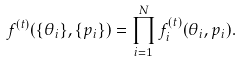Convert formula to latex. <formula><loc_0><loc_0><loc_500><loc_500>f ^ { ( t ) } ( \{ \theta _ { i } \} , \{ p _ { i } \} ) = \prod ^ { N } _ { i = 1 } f ^ { ( t ) } _ { i } ( \theta _ { i } , p _ { i } ) .</formula> 